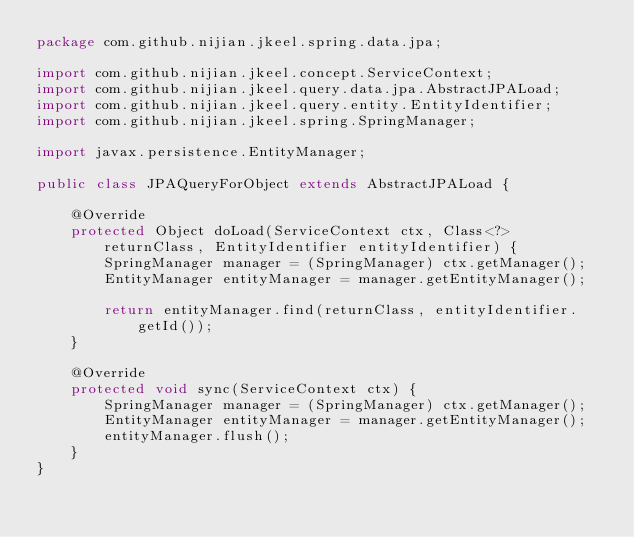Convert code to text. <code><loc_0><loc_0><loc_500><loc_500><_Java_>package com.github.nijian.jkeel.spring.data.jpa;

import com.github.nijian.jkeel.concept.ServiceContext;
import com.github.nijian.jkeel.query.data.jpa.AbstractJPALoad;
import com.github.nijian.jkeel.query.entity.EntityIdentifier;
import com.github.nijian.jkeel.spring.SpringManager;

import javax.persistence.EntityManager;

public class JPAQueryForObject extends AbstractJPALoad {

    @Override
    protected Object doLoad(ServiceContext ctx, Class<?> returnClass, EntityIdentifier entityIdentifier) {
        SpringManager manager = (SpringManager) ctx.getManager();
        EntityManager entityManager = manager.getEntityManager();

        return entityManager.find(returnClass, entityIdentifier.getId());
    }

    @Override
    protected void sync(ServiceContext ctx) {
        SpringManager manager = (SpringManager) ctx.getManager();
        EntityManager entityManager = manager.getEntityManager();
        entityManager.flush();
    }
}
</code> 